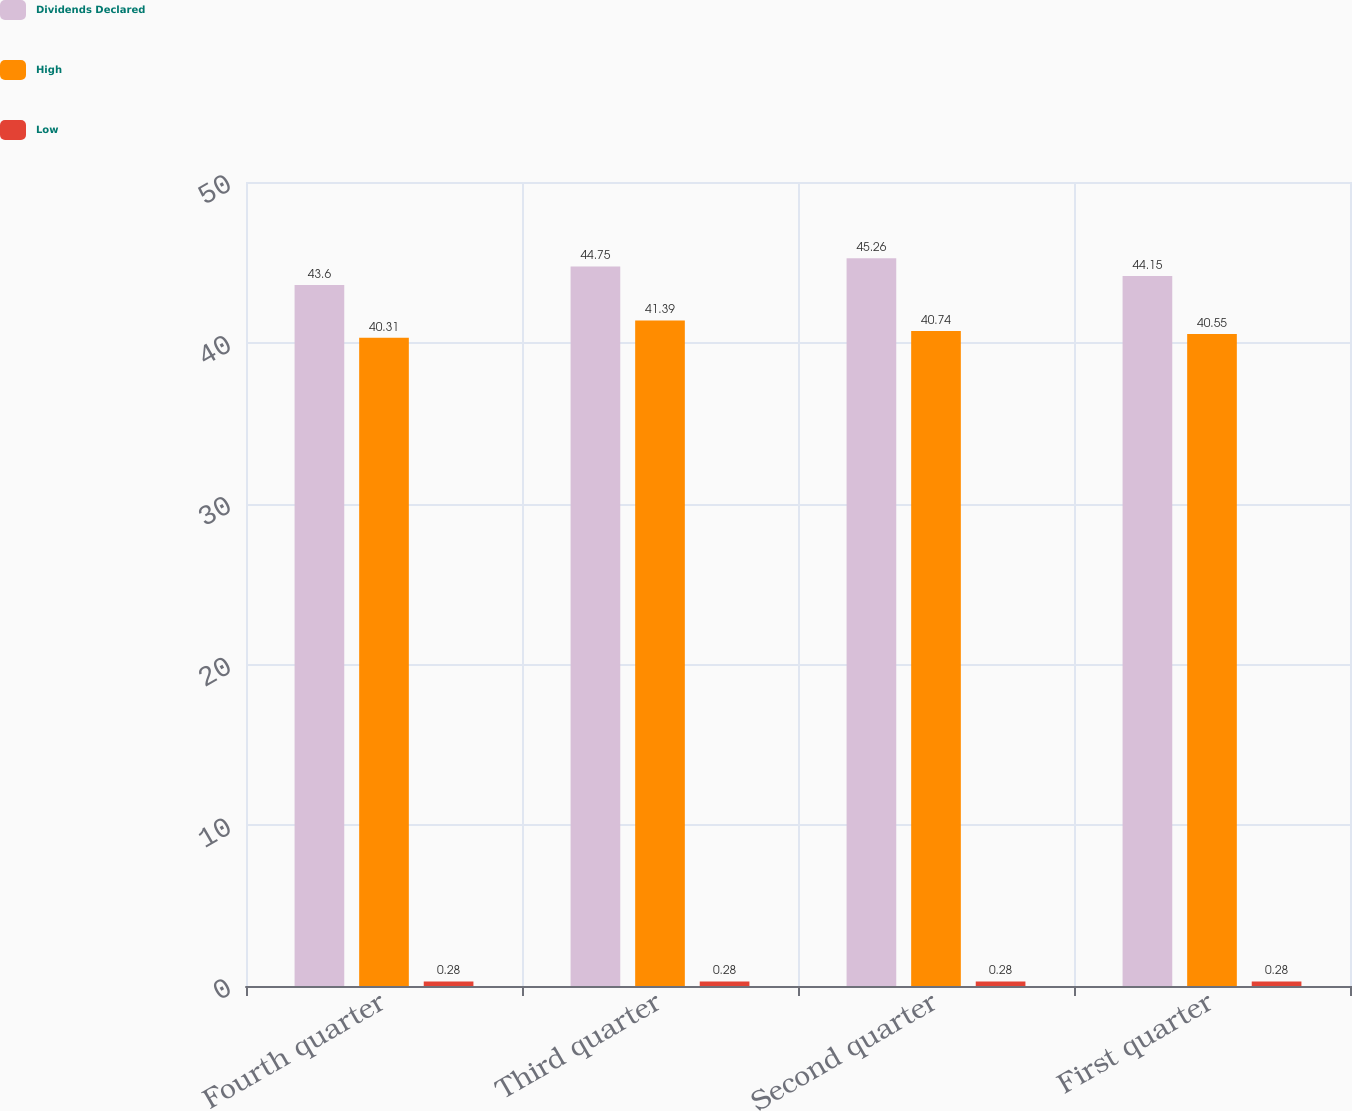Convert chart to OTSL. <chart><loc_0><loc_0><loc_500><loc_500><stacked_bar_chart><ecel><fcel>Fourth quarter<fcel>Third quarter<fcel>Second quarter<fcel>First quarter<nl><fcel>Dividends Declared<fcel>43.6<fcel>44.75<fcel>45.26<fcel>44.15<nl><fcel>High<fcel>40.31<fcel>41.39<fcel>40.74<fcel>40.55<nl><fcel>Low<fcel>0.28<fcel>0.28<fcel>0.28<fcel>0.28<nl></chart> 